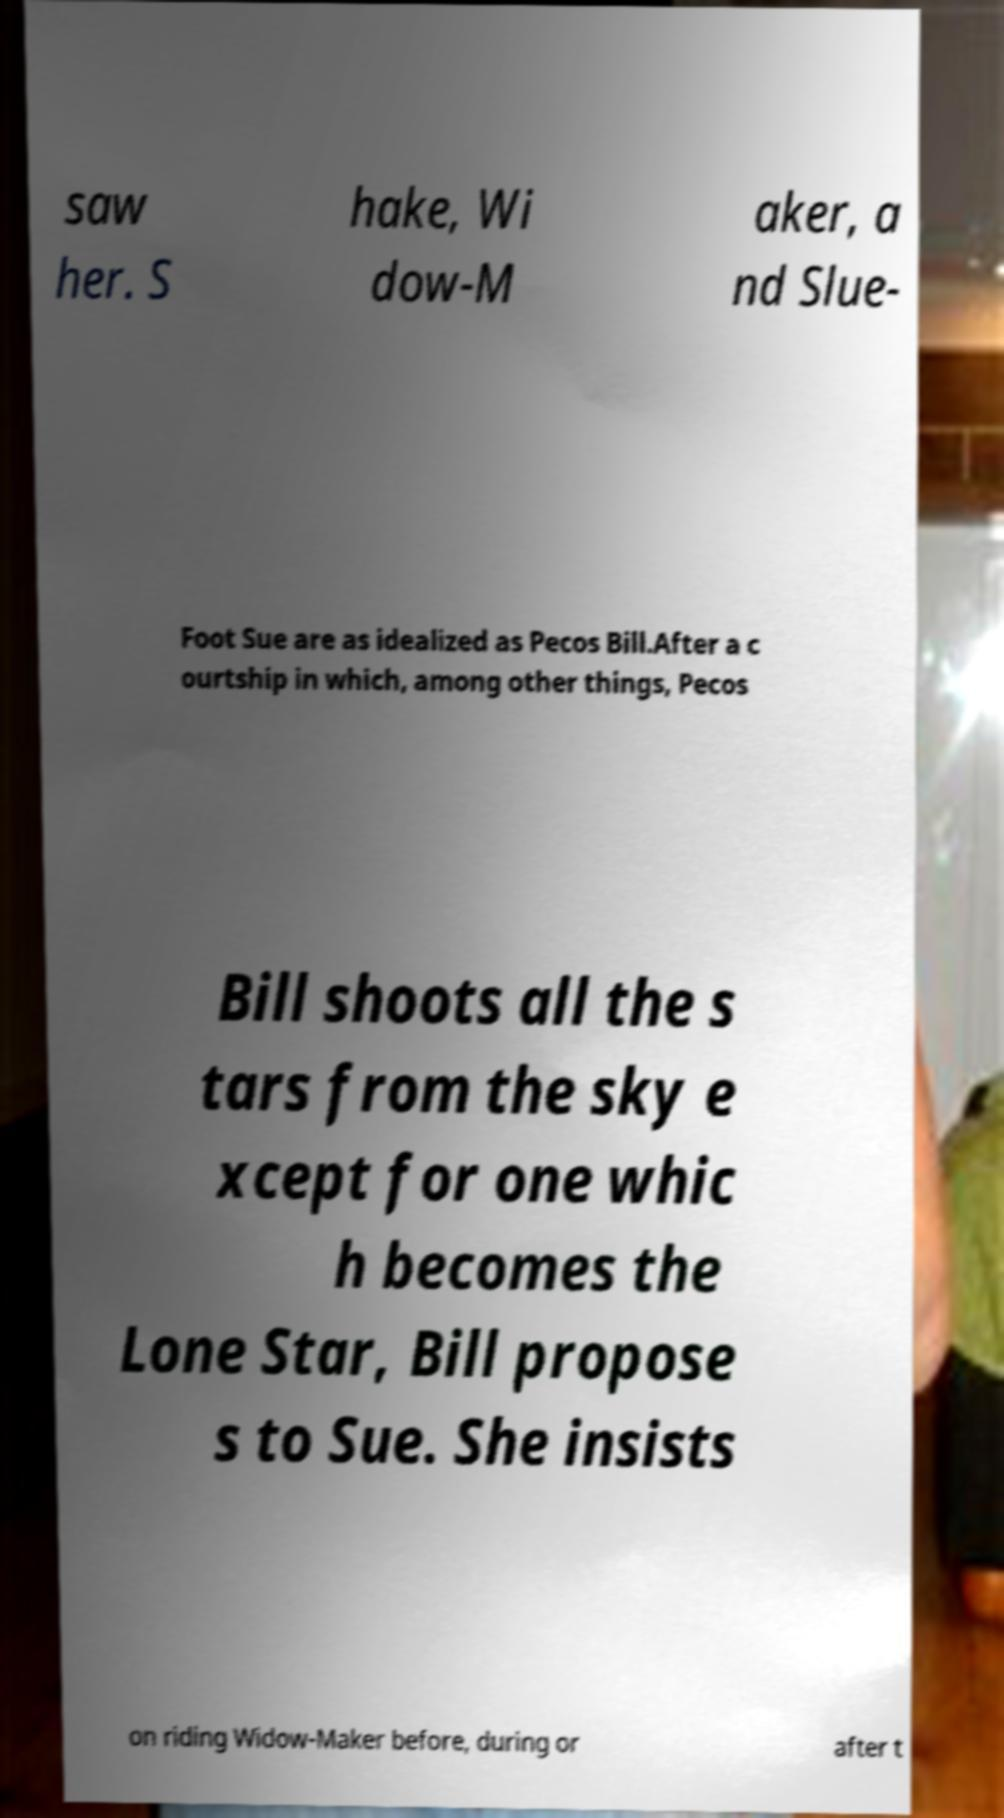For documentation purposes, I need the text within this image transcribed. Could you provide that? saw her. S hake, Wi dow-M aker, a nd Slue- Foot Sue are as idealized as Pecos Bill.After a c ourtship in which, among other things, Pecos Bill shoots all the s tars from the sky e xcept for one whic h becomes the Lone Star, Bill propose s to Sue. She insists on riding Widow-Maker before, during or after t 